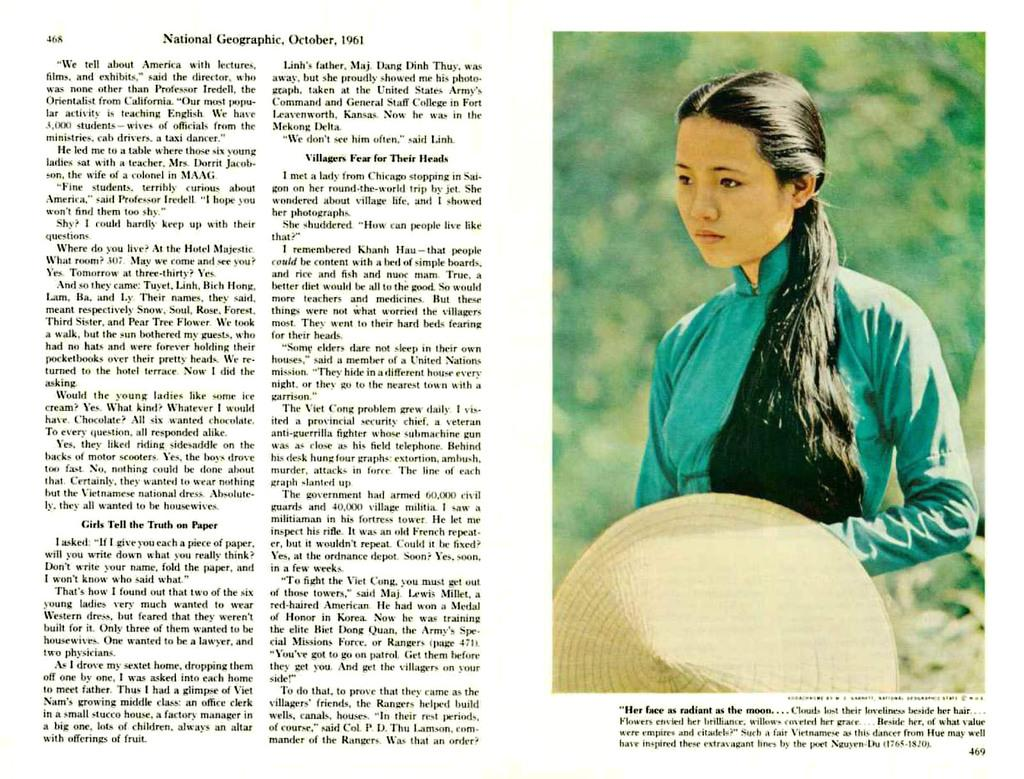What is the main subject of the image? There is a beautiful woman in the image. What is the woman holding in her hands? The woman is holding a hat in her hands. What color is the t-shirt the woman is wearing? The woman is wearing a green color t-shirt. What can be seen on the left side of the image? There is a matter on the left side of the image, which appears to be a paper in a book. What type of decision can be seen being made by the woman in the image? There is no indication in the image that the woman is making a decision. Can you tell me how many matches are visible in the image? There are no matches present in the image. 